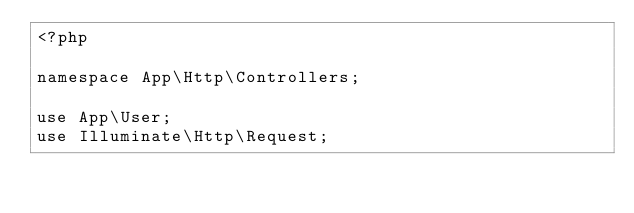<code> <loc_0><loc_0><loc_500><loc_500><_PHP_><?php

namespace App\Http\Controllers;

use App\User;
use Illuminate\Http\Request;</code> 